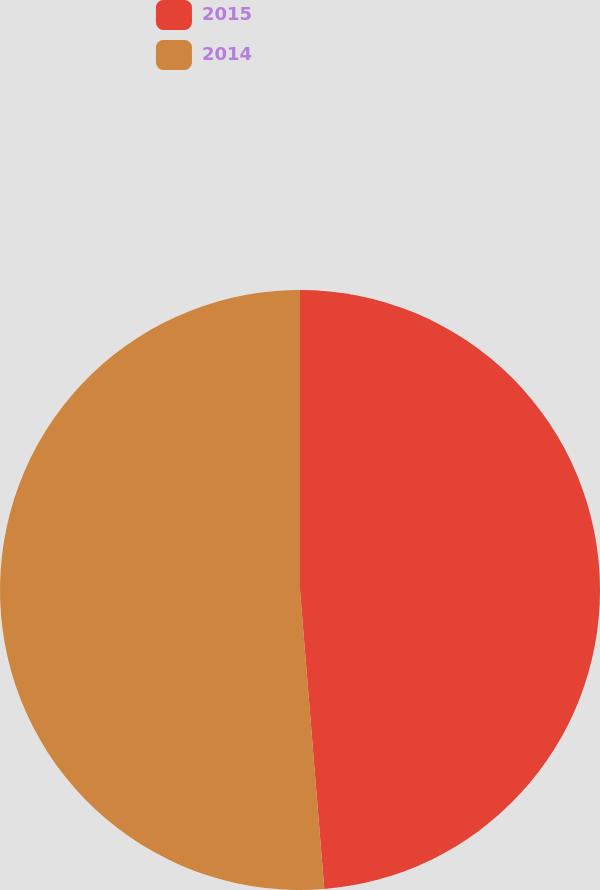Convert chart. <chart><loc_0><loc_0><loc_500><loc_500><pie_chart><fcel>2015<fcel>2014<nl><fcel>48.71%<fcel>51.29%<nl></chart> 